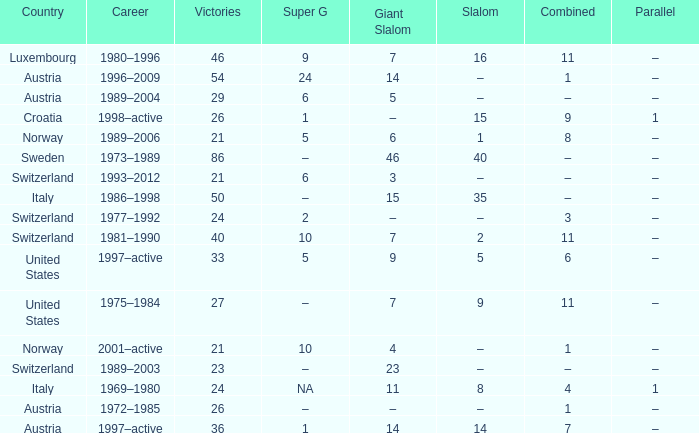What Giant Slalom has Victories larger than 27, a Slalom of –, and a Career of 1996–2009? 14.0. Can you give me this table as a dict? {'header': ['Country', 'Career', 'Victories', 'Super G', 'Giant Slalom', 'Slalom', 'Combined', 'Parallel'], 'rows': [['Luxembourg', '1980–1996', '46', '9', '7', '16', '11', '–'], ['Austria', '1996–2009', '54', '24', '14', '–', '1', '–'], ['Austria', '1989–2004', '29', '6', '5', '–', '–', '–'], ['Croatia', '1998–active', '26', '1', '–', '15', '9', '1'], ['Norway', '1989–2006', '21', '5', '6', '1', '8', '–'], ['Sweden', '1973–1989', '86', '–', '46', '40', '–', '–'], ['Switzerland', '1993–2012', '21', '6', '3', '–', '–', '–'], ['Italy', '1986–1998', '50', '–', '15', '35', '–', '–'], ['Switzerland', '1977–1992', '24', '2', '–', '–', '3', '–'], ['Switzerland', '1981–1990', '40', '10', '7', '2', '11', '–'], ['United States', '1997–active', '33', '5', '9', '5', '6', '–'], ['United States', '1975–1984', '27', '–', '7', '9', '11', '–'], ['Norway', '2001–active', '21', '10', '4', '–', '1', '–'], ['Switzerland', '1989–2003', '23', '–', '23', '–', '–', '–'], ['Italy', '1969–1980', '24', 'NA', '11', '8', '4', '1'], ['Austria', '1972–1985', '26', '–', '–', '–', '1', '–'], ['Austria', '1997–active', '36', '1', '14', '14', '7', '–']]} 